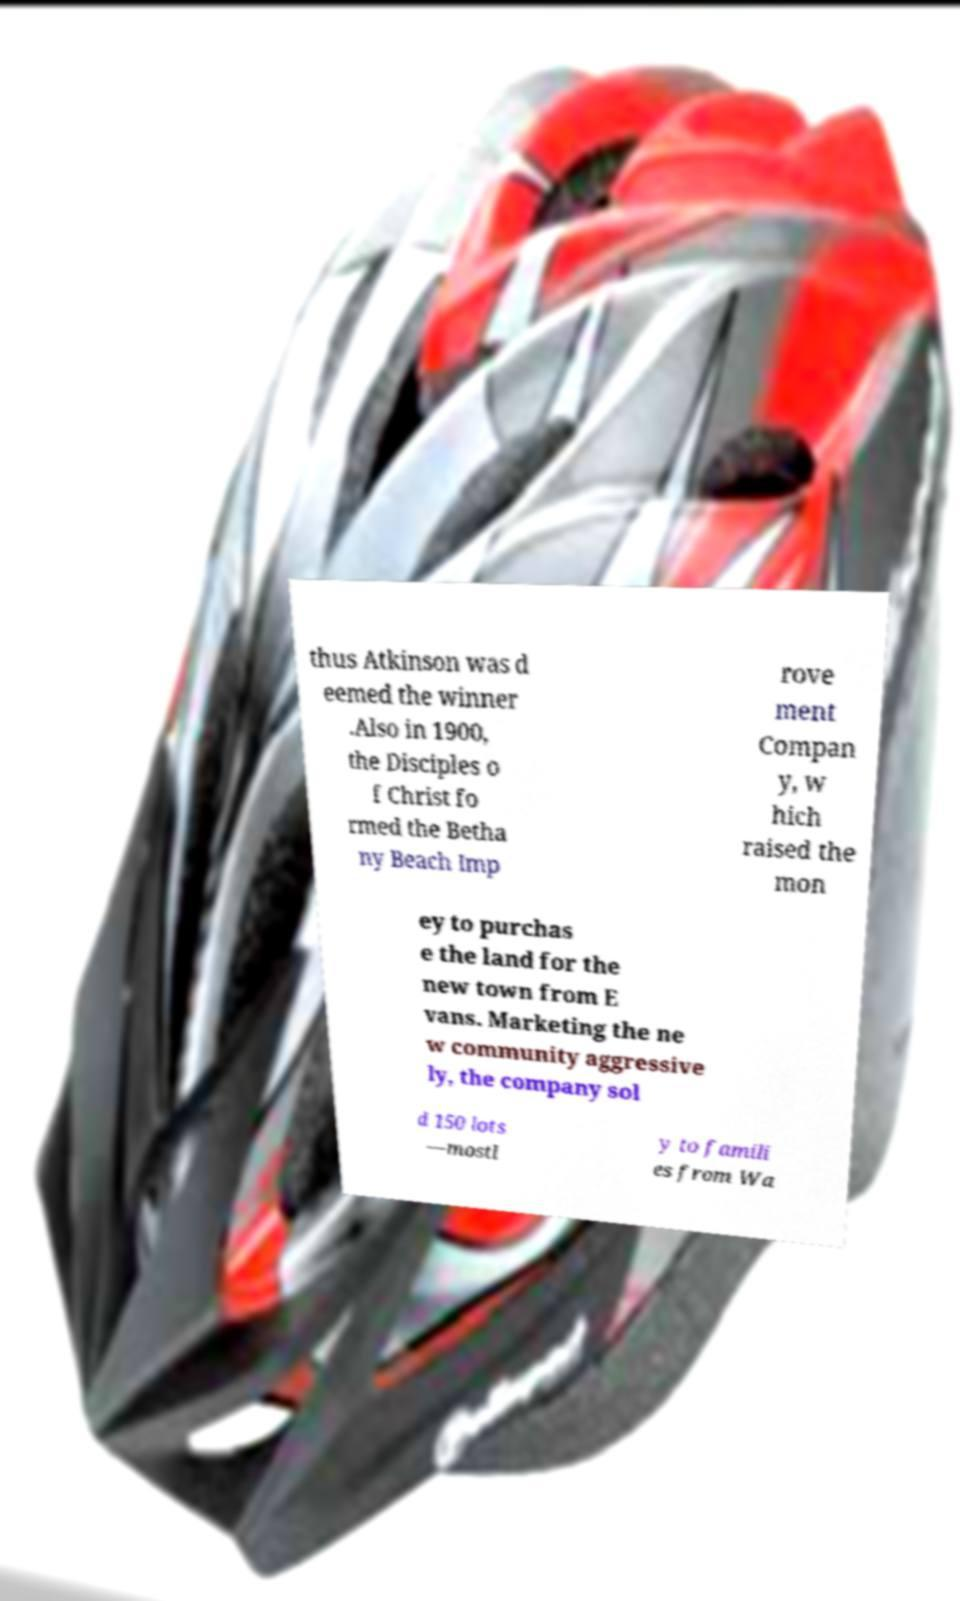For documentation purposes, I need the text within this image transcribed. Could you provide that? thus Atkinson was d eemed the winner .Also in 1900, the Disciples o f Christ fo rmed the Betha ny Beach Imp rove ment Compan y, w hich raised the mon ey to purchas e the land for the new town from E vans. Marketing the ne w community aggressive ly, the company sol d 150 lots —mostl y to famili es from Wa 